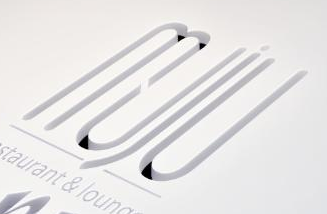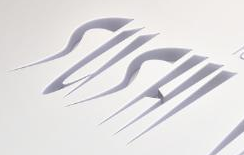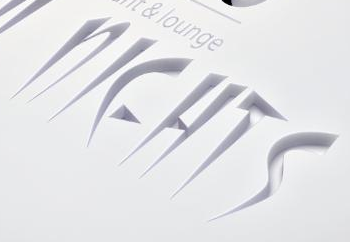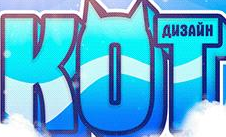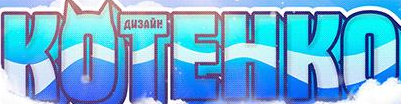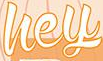What text is displayed in these images sequentially, separated by a semicolon? muju; SUSHI; NIEHTS; KOT; KOTEHKO; hey 